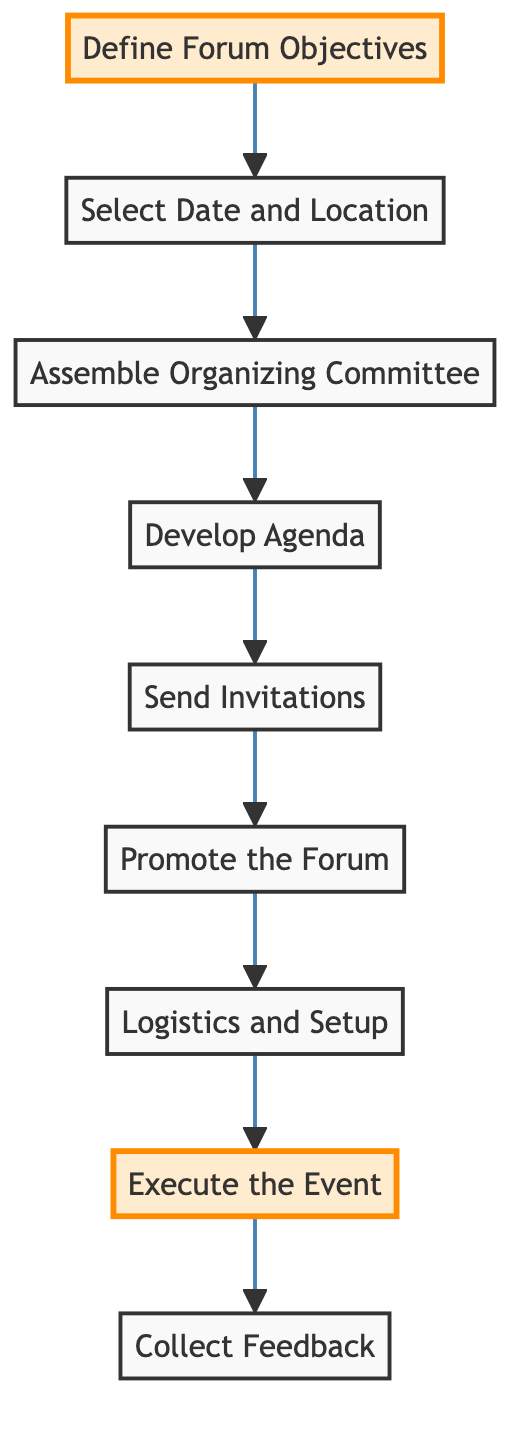What is the first step in the journey of organizing a political forum? The first step is to "Define Forum Objectives," as indicated by the starting node in the flowchart.
Answer: Define Forum Objectives How many total steps are represented in the flowchart? By counting each unique process in the flowchart, there are 9 steps indicated.
Answer: 9 What comes immediately after "Select Date and Location"? Following "Select Date and Location," the next step is "Assemble Organizing Committee."
Answer: Assemble Organizing Committee What is the final step in the process? The final step is to "Collect Feedback," marking the conclusion of the journey.
Answer: Collect Feedback Which step involves inviting speakers and attendees? The step involving inviting speakers and attendees is "Send Invitations."
Answer: Send Invitations What activities are included in the "Logistics and Setup"? "Logistics and Setup" involves arranging seating, audio-visual equipment, and materials for the forum.
Answer: Seating, audio-visual equipment, materials How many steps occur before executing the event? There are 7 steps occurring before "Execute the Event" in the flowchart.
Answer: 7 Which two steps are highlighted in the diagram? The highlighted steps are "Define Forum Objectives" and "Execute the Event."
Answer: Define Forum Objectives and Execute the Event What is the purpose of "Promote the Forum"? The purpose is to raise awareness and encourage attendance through various channels.
Answer: Raise awareness and encourage attendance 